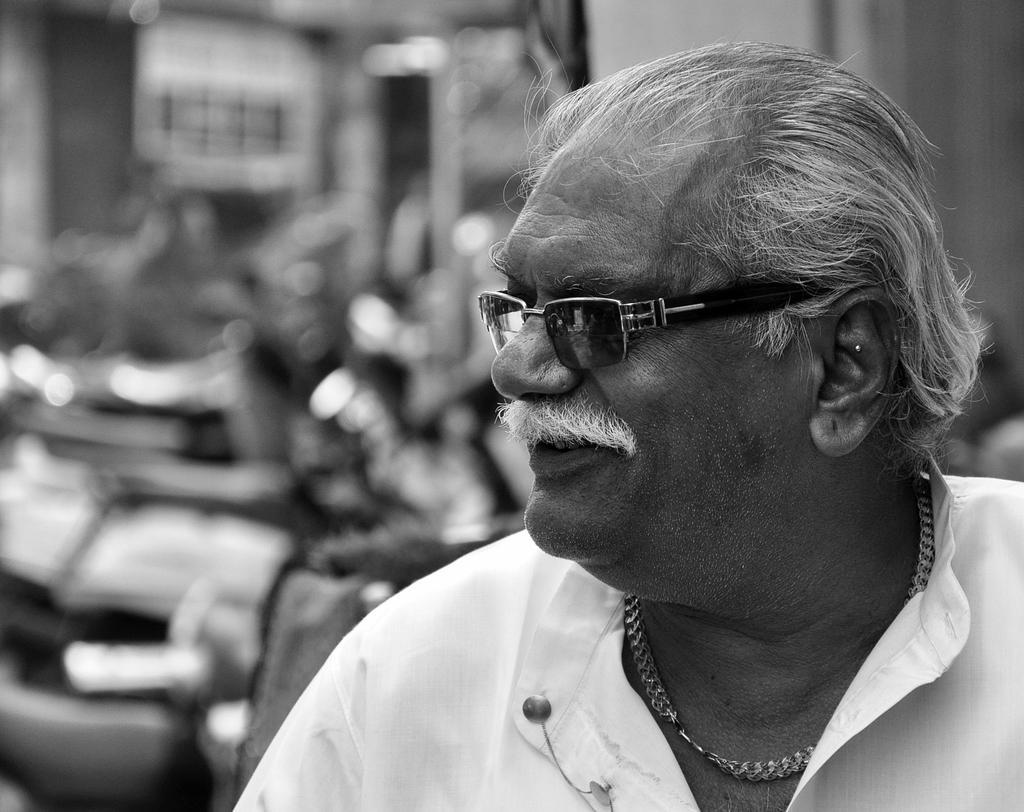Describe this image in one or two sentences. In this image we can see a black and white picture of a person wearing white shirt and spectacles. 